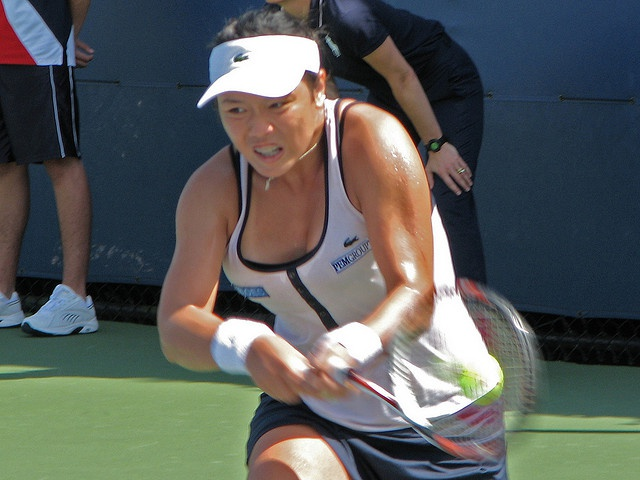Describe the objects in this image and their specific colors. I can see people in maroon, brown, white, and gray tones, people in maroon, black, and gray tones, tennis racket in maroon, gray, white, and darkgray tones, people in maroon, black, and gray tones, and sports ball in maroon, ivory, khaki, and lightgreen tones in this image. 